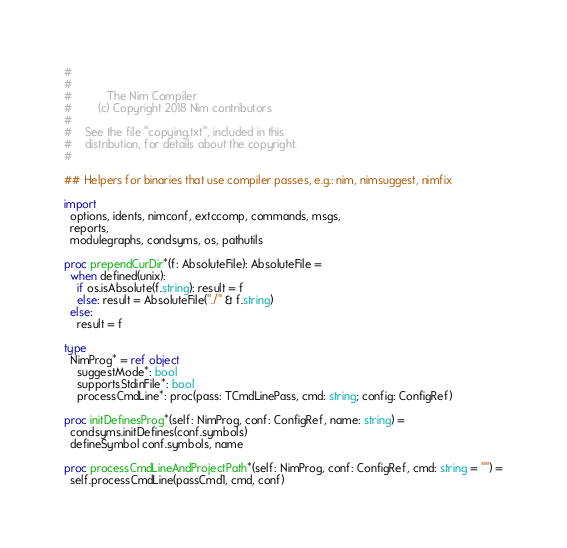Convert code to text. <code><loc_0><loc_0><loc_500><loc_500><_Nim_>#
#
#           The Nim Compiler
#        (c) Copyright 2018 Nim contributors
#
#    See the file "copying.txt", included in this
#    distribution, for details about the copyright.
#

## Helpers for binaries that use compiler passes, e.g.: nim, nimsuggest, nimfix

import
  options, idents, nimconf, extccomp, commands, msgs,
  reports,
  modulegraphs, condsyms, os, pathutils

proc prependCurDir*(f: AbsoluteFile): AbsoluteFile =
  when defined(unix):
    if os.isAbsolute(f.string): result = f
    else: result = AbsoluteFile("./" & f.string)
  else:
    result = f

type
  NimProg* = ref object
    suggestMode*: bool
    supportsStdinFile*: bool
    processCmdLine*: proc(pass: TCmdLinePass, cmd: string; config: ConfigRef)

proc initDefinesProg*(self: NimProg, conf: ConfigRef, name: string) =
  condsyms.initDefines(conf.symbols)
  defineSymbol conf.symbols, name

proc processCmdLineAndProjectPath*(self: NimProg, conf: ConfigRef, cmd: string = "") =
  self.processCmdLine(passCmd1, cmd, conf)</code> 